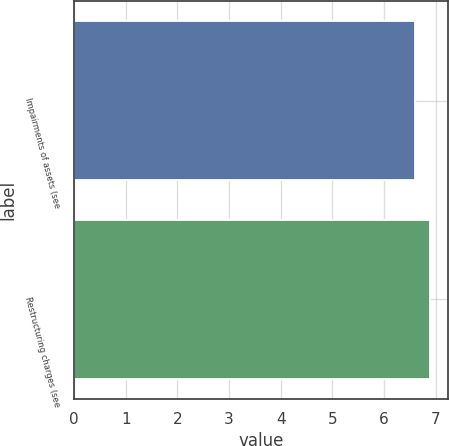<chart> <loc_0><loc_0><loc_500><loc_500><bar_chart><fcel>Impairments of assets (see<fcel>Restructuring charges (see<nl><fcel>6.6<fcel>6.9<nl></chart> 